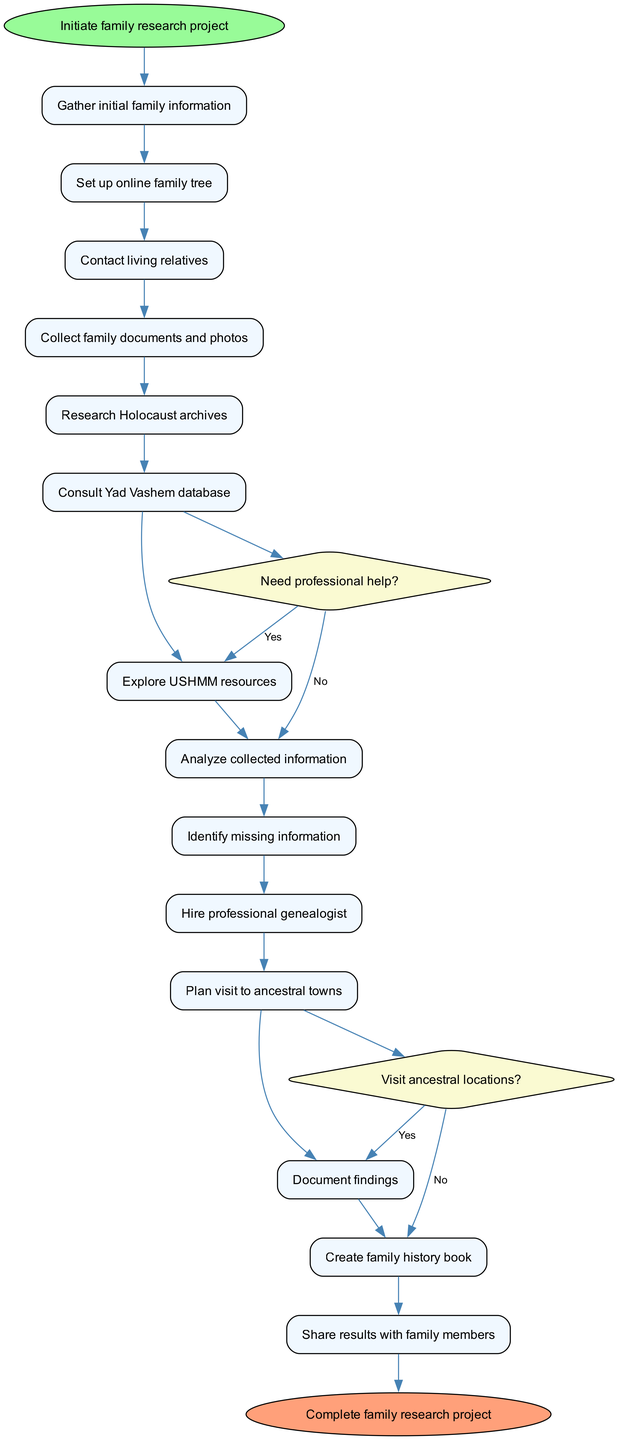What is the first activity in the diagram? The diagram starts with the node labeled "Initiate family research project," which is the first activity indicated. Thus, it specifically details what the family research project focuses on.
Answer: Initiate family research project How many activities are listed in the diagram? The diagram contains a total of 13 activities listed, detailing the steps involved in the family research project from start to finish.
Answer: 13 What decision follows collecting family documents and photos? After the activity "Collect family documents and photos," the diagram presents a decision labeled "Need professional help?", indicating a branching point based on whether assistance is required or not.
Answer: Need professional help? How many total decisions are in the diagram? There are two decisions presented in the diagram, specifically "Need professional help?" and "Visit ancestral locations?", which affect the subsequent flow of activities.
Answer: 2 If professional help is not needed, what is the next activity? If the decision "Need professional help?" leads to the "No" response, the diagram indicates that the next activity is "Research Holocaust archives," which continues the research process without external assistance.
Answer: Research Holocaust archives After analyzing collected information, what is one identified step next? Following the activity "Analyze collected information," the next step indicated in the diagram is to "Identify missing information," where gaps in knowledge or resources are recognized.
Answer: Identify missing information What is the end node labeled in the diagram? The diagram's end node is labeled "Complete family research project," which signifies the conclusion of the entire process once all research activities and documentation are finalized.
Answer: Complete family research project What outcome occurs after documenting findings? Once the activity "Document findings" is completed, the diagram directs to the final step, which is to "Create family history book," specifying how the documented research is to be compiled and presented.
Answer: Create family history book 